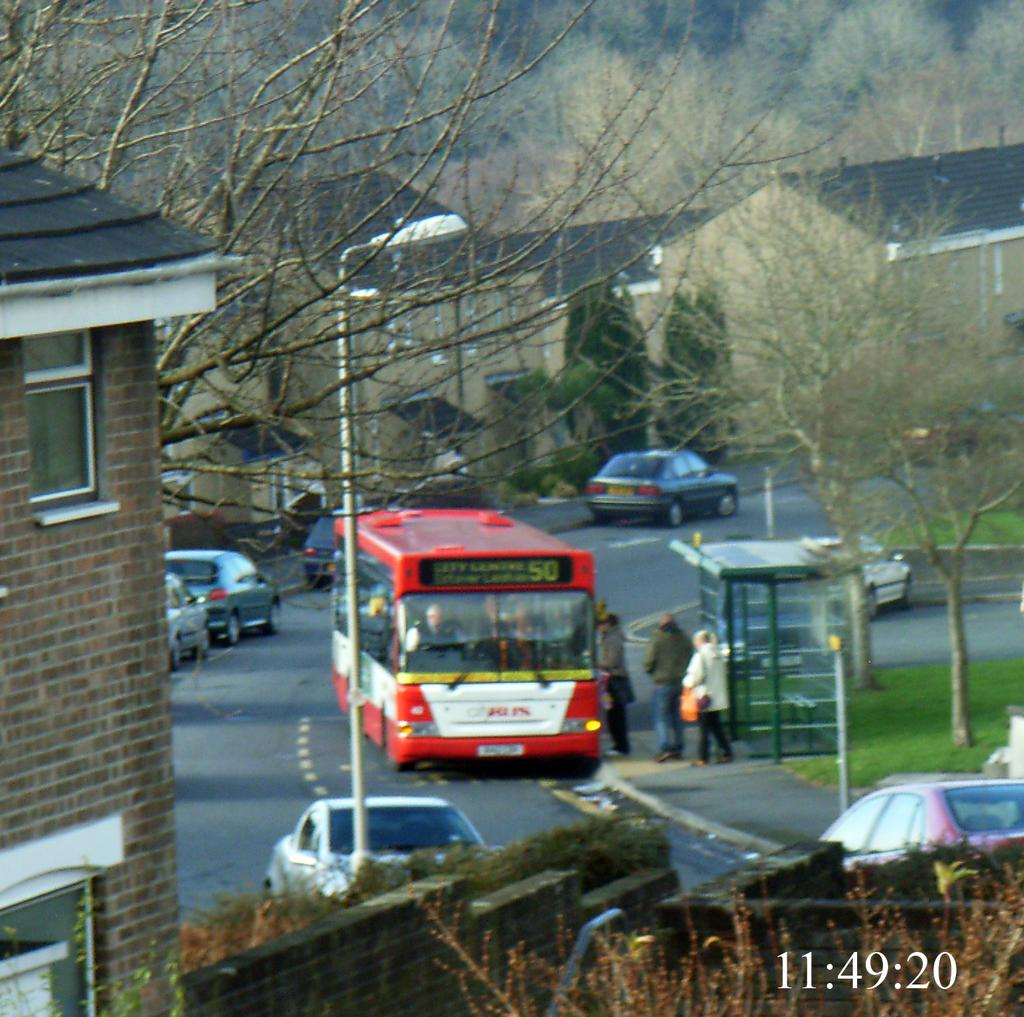What structure is located on the left side of the image? There is a building on the left side of the image. What can be seen in the middle of the image? There are trees and vehicles in the middle of the image. Are there any people visible in the image? Yes, there are some persons in the middle of the image. What type of quill is being used by the uncle in the image? There is no uncle or quill present in the image. What impulse might have caused the building to move in the image? The building does not move in the image; it is stationary. 